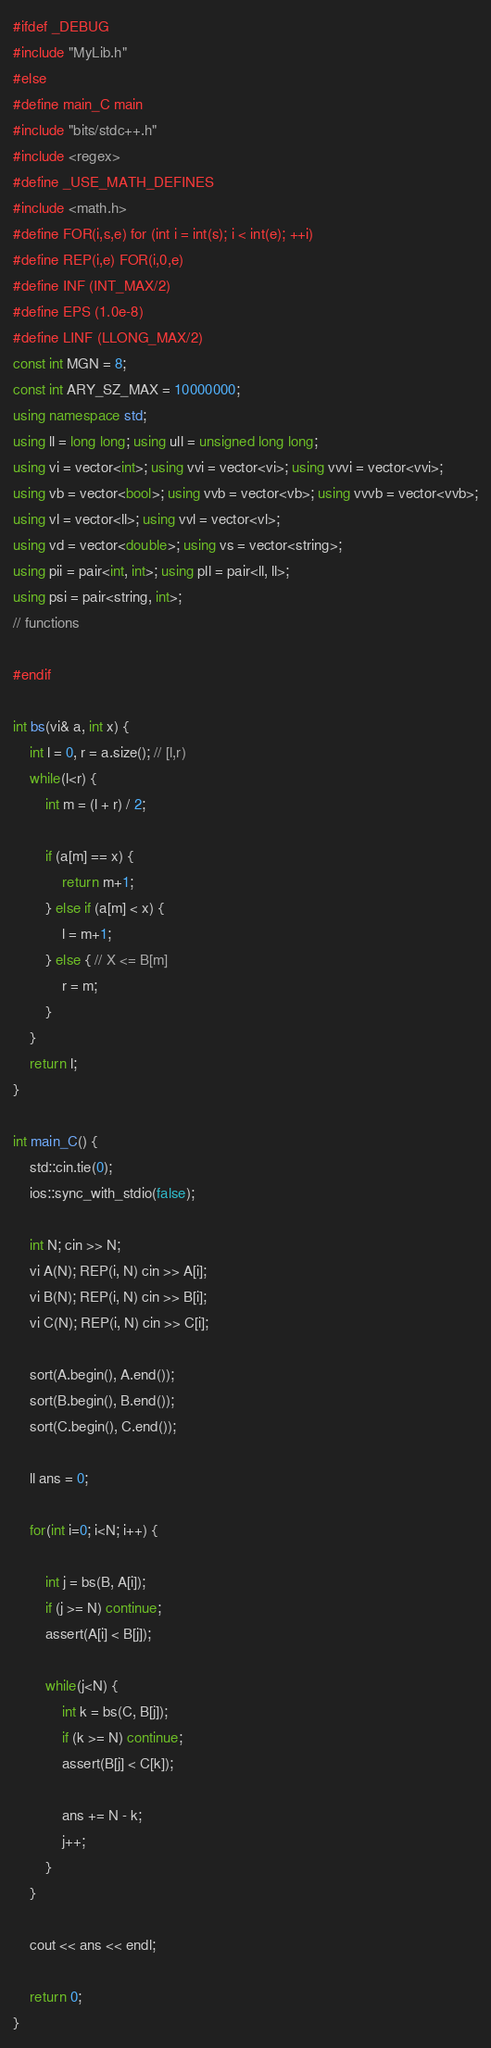Convert code to text. <code><loc_0><loc_0><loc_500><loc_500><_C++_>#ifdef _DEBUG
#include "MyLib.h"
#else
#define main_C main
#include "bits/stdc++.h"
#include <regex>
#define _USE_MATH_DEFINES
#include <math.h>
#define FOR(i,s,e) for (int i = int(s); i < int(e); ++i)
#define REP(i,e) FOR(i,0,e)
#define INF (INT_MAX/2)
#define EPS (1.0e-8)
#define LINF (LLONG_MAX/2)
const int MGN = 8;
const int ARY_SZ_MAX = 10000000;
using namespace std;
using ll = long long; using ull = unsigned long long;
using vi = vector<int>; using vvi = vector<vi>; using vvvi = vector<vvi>;
using vb = vector<bool>; using vvb = vector<vb>; using vvvb = vector<vvb>;
using vl = vector<ll>; using vvl = vector<vl>;
using vd = vector<double>; using vs = vector<string>;
using pii = pair<int, int>; using pll = pair<ll, ll>;
using psi = pair<string, int>;
// functions

#endif

int bs(vi& a, int x) {
    int l = 0, r = a.size(); // [l,r)
    while(l<r) {
        int m = (l + r) / 2;

        if (a[m] == x) {
            return m+1;
        } else if (a[m] < x) {
            l = m+1;
        } else { // X <= B[m]
            r = m;
        }
    }
    return l;
}

int main_C() {
    std::cin.tie(0);
    ios::sync_with_stdio(false);

    int N; cin >> N;
    vi A(N); REP(i, N) cin >> A[i];
    vi B(N); REP(i, N) cin >> B[i];
    vi C(N); REP(i, N) cin >> C[i];

    sort(A.begin(), A.end());
    sort(B.begin(), B.end());
    sort(C.begin(), C.end());

    ll ans = 0;

    for(int i=0; i<N; i++) {

        int j = bs(B, A[i]);
        if (j >= N) continue;
        assert(A[i] < B[j]);
        
        while(j<N) {
            int k = bs(C, B[j]);
            if (k >= N) continue;
            assert(B[j] < C[k]);

            ans += N - k;
            j++;
        }
    }
    
    cout << ans << endl;

    return 0;
}</code> 